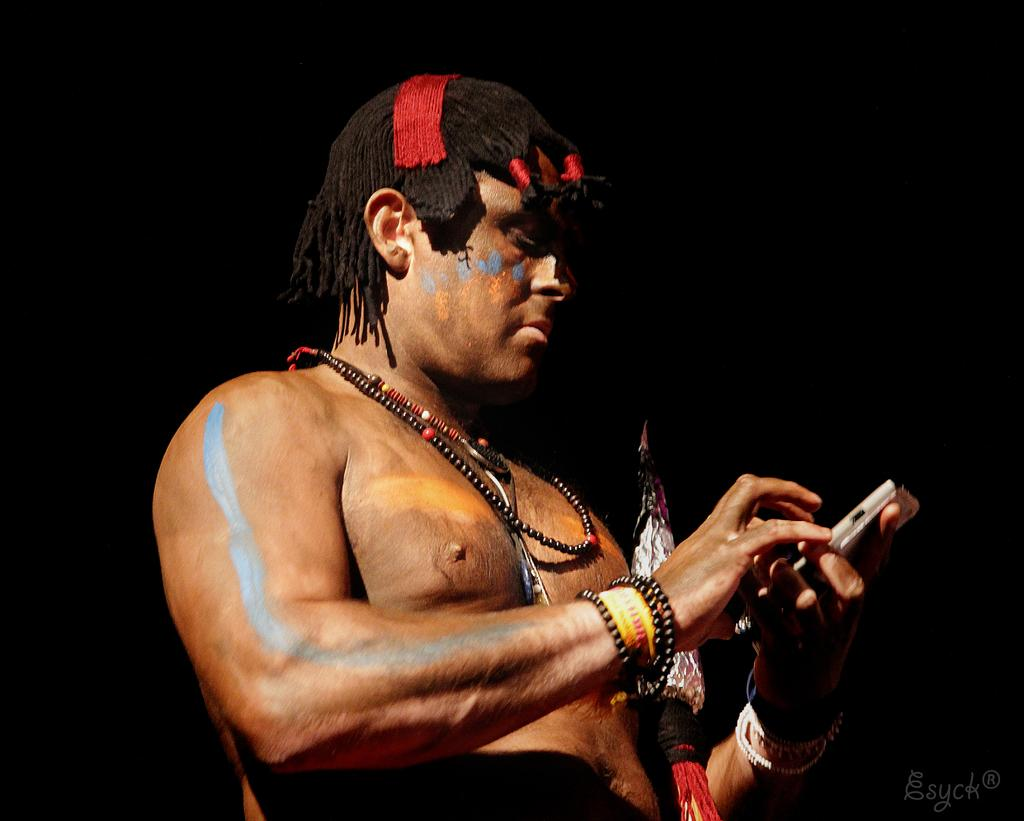What is the main subject of the image? The main subject of the image is a man. What is the man doing in the image? The man is standing in the image. What object is the man holding in his hand? The man is holding a phone in his hand. What type of accessory is the man wearing? The man is wearing lockets. Can you describe the man's appearance in terms of colors? There are colors on the man's body. What is the color of the background in the image? The background of the image is dark. What type of property does the man own in the image? There is no information about the man owning any property in the image. What ingredients are used to make the stew in the image? There is no stew present in the image. 